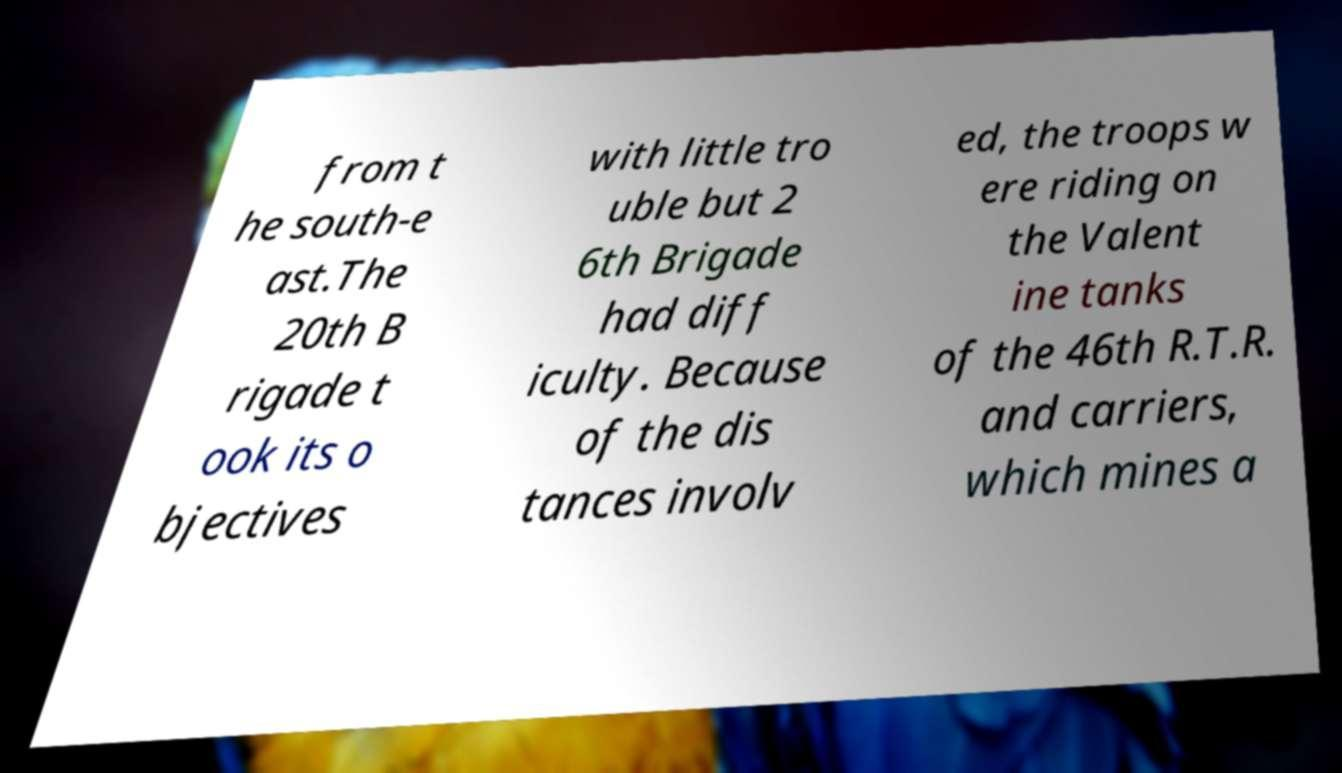Can you read and provide the text displayed in the image?This photo seems to have some interesting text. Can you extract and type it out for me? from t he south-e ast.The 20th B rigade t ook its o bjectives with little tro uble but 2 6th Brigade had diff iculty. Because of the dis tances involv ed, the troops w ere riding on the Valent ine tanks of the 46th R.T.R. and carriers, which mines a 